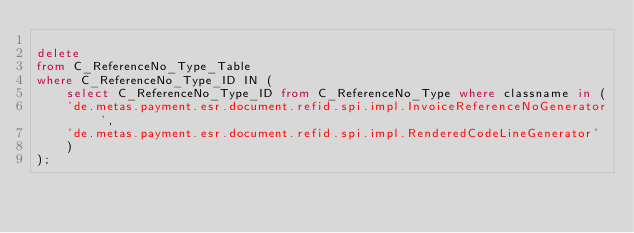Convert code to text. <code><loc_0><loc_0><loc_500><loc_500><_SQL_>
delete
from C_ReferenceNo_Type_Table 
where C_ReferenceNo_Type_ID IN (
	select C_ReferenceNo_Type_ID from C_ReferenceNo_Type where classname in (
	'de.metas.payment.esr.document.refid.spi.impl.InvoiceReferenceNoGenerator',
	'de.metas.payment.esr.document.refid.spi.impl.RenderedCodeLineGenerator'
	)
);
</code> 